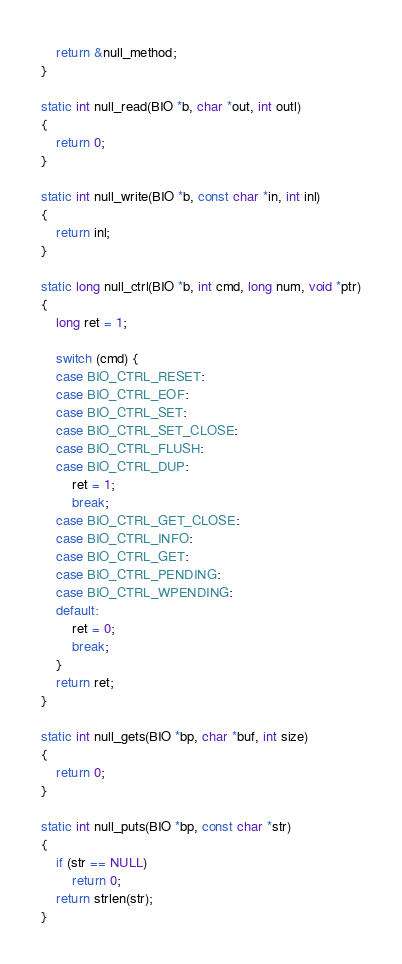Convert code to text. <code><loc_0><loc_0><loc_500><loc_500><_C_>    return &null_method;
}

static int null_read(BIO *b, char *out, int outl)
{
    return 0;
}

static int null_write(BIO *b, const char *in, int inl)
{
    return inl;
}

static long null_ctrl(BIO *b, int cmd, long num, void *ptr)
{
    long ret = 1;

    switch (cmd) {
    case BIO_CTRL_RESET:
    case BIO_CTRL_EOF:
    case BIO_CTRL_SET:
    case BIO_CTRL_SET_CLOSE:
    case BIO_CTRL_FLUSH:
    case BIO_CTRL_DUP:
        ret = 1;
        break;
    case BIO_CTRL_GET_CLOSE:
    case BIO_CTRL_INFO:
    case BIO_CTRL_GET:
    case BIO_CTRL_PENDING:
    case BIO_CTRL_WPENDING:
    default:
        ret = 0;
        break;
    }
    return ret;
}

static int null_gets(BIO *bp, char *buf, int size)
{
    return 0;
}

static int null_puts(BIO *bp, const char *str)
{
    if (str == NULL)
        return 0;
    return strlen(str);
}
</code> 